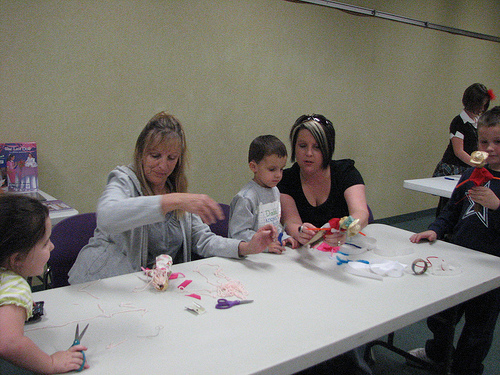<image>
Can you confirm if the woman is on the chair? Yes. Looking at the image, I can see the woman is positioned on top of the chair, with the chair providing support. 